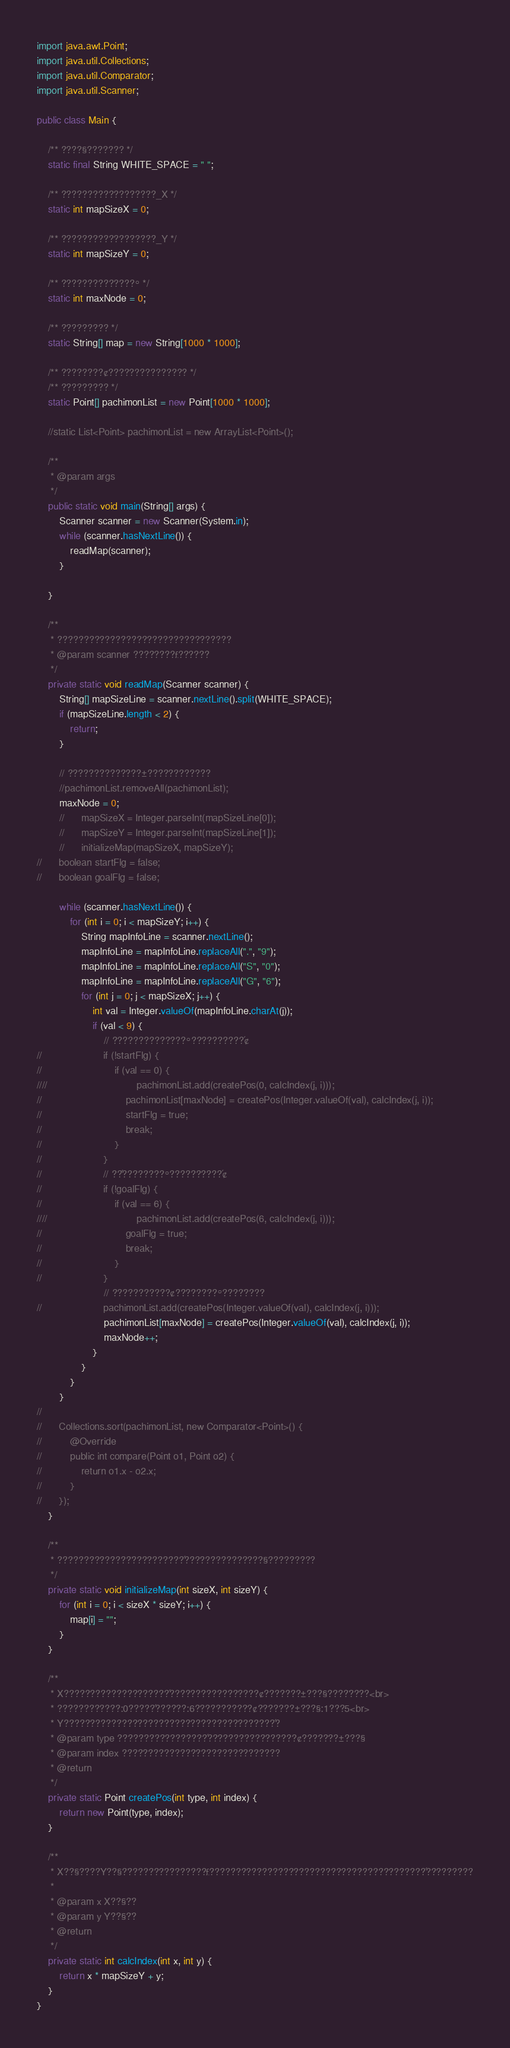<code> <loc_0><loc_0><loc_500><loc_500><_Java_>import java.awt.Point;
import java.util.Collections;
import java.util.Comparator;
import java.util.Scanner;

public class Main {

	/** ????§??????? */
	static final String WHITE_SPACE = " ";

	/** ??????????????????_X */
	static int mapSizeX = 0;

	/** ??????????????????_Y */
	static int mapSizeY = 0;

	/** ??????????????° */
	static int maxNode = 0;

	/** ????????? */
	static String[] map = new String[1000 * 1000];

	/** ????????¢??????????????? */
	/** ????????? */
	static Point[] pachimonList = new Point[1000 * 1000];

	//static List<Point> pachimonList = new ArrayList<Point>();

	/**
	 * @param args
	 */
	public static void main(String[] args) {
		Scanner scanner = new Scanner(System.in);
		while (scanner.hasNextLine()) {
			readMap(scanner);
		}

	}

	/**
	 * ?????????????????????????????????
	 * @param scanner ????????£??????
	 */
	private static void readMap(Scanner scanner) {
		String[] mapSizeLine = scanner.nextLine().split(WHITE_SPACE);
		if (mapSizeLine.length < 2) {
			return;
		}

		// ??????????????±????????????
		//pachimonList.removeAll(pachimonList);
		maxNode = 0;
		//		mapSizeX = Integer.parseInt(mapSizeLine[0]);
		//		mapSizeY = Integer.parseInt(mapSizeLine[1]);
		//		initializeMap(mapSizeX, mapSizeY);
//		boolean startFlg = false;
//		boolean goalFlg = false;

		while (scanner.hasNextLine()) {
			for (int i = 0; i < mapSizeY; i++) {
				String mapInfoLine = scanner.nextLine();
				mapInfoLine = mapInfoLine.replaceAll(".", "9");
				mapInfoLine = mapInfoLine.replaceAll("S", "0");
				mapInfoLine = mapInfoLine.replaceAll("G", "6");
				for (int j = 0; j < mapSizeX; j++) {
					int val = Integer.valueOf(mapInfoLine.charAt(j));
					if (val < 9) {
						// ??????????????°??????????´¢
//						if (!startFlg) {
//							if (val == 0) {
////								pachimonList.add(createPos(0, calcIndex(j, i)));
//								pachimonList[maxNode] = createPos(Integer.valueOf(val), calcIndex(j, i));
//								startFlg = true;
//								break;
//							}
//						}
//						// ??´????????°??????????´¢
//						if (!goalFlg) {
//							if (val == 6) {
////								pachimonList.add(createPos(6, calcIndex(j, i)));
//								goalFlg = true;
//								break;
//							}
//						}
						// ???????????¢????????°????¨????
//						pachimonList.add(createPos(Integer.valueOf(val), calcIndex(j, i)));
						pachimonList[maxNode] = createPos(Integer.valueOf(val), calcIndex(j, i));
						maxNode++;
					}
				}
			}
		}
//
//		Collections.sort(pachimonList, new Comparator<Point>() {
//			@Override
//			public int compare(Point o1, Point o2) {
//				return o1.x - o2.x;
//			}
//		});
	}

	/**
	 * ??????????????¨??????????´???????????????§?????????
	 */
	private static void initializeMap(int sizeX, int sizeY) {
		for (int i = 0; i < sizeX * sizeY; i++) {
			map[i] = "";
		}
	}

	/**
	 * X????????????????????´?????????????????¢???????±???§????¨????<br>
	 * ????????????:0?????´??????:6???????????¢???????±???§:1???5<br>
	 * Y????????????????????????????????????????´?
	 * @param type ?????????????????´?????????????????¢???????±???§
	 * @param index ??????????????????????????????
	 * @return
	 */
	private static Point createPos(int type, int index) {
		return new Point(type, index);
	}

	/**
	 * X??§?¨???¨Y??§?¨???????????????£?????????????????????????????????????????´?????????
	 *
	 * @param x X??§?¨?
	 * @param y Y??§?¨?
	 * @return
	 */
	private static int calcIndex(int x, int y) {
		return x * mapSizeY + y;
	}
}</code> 